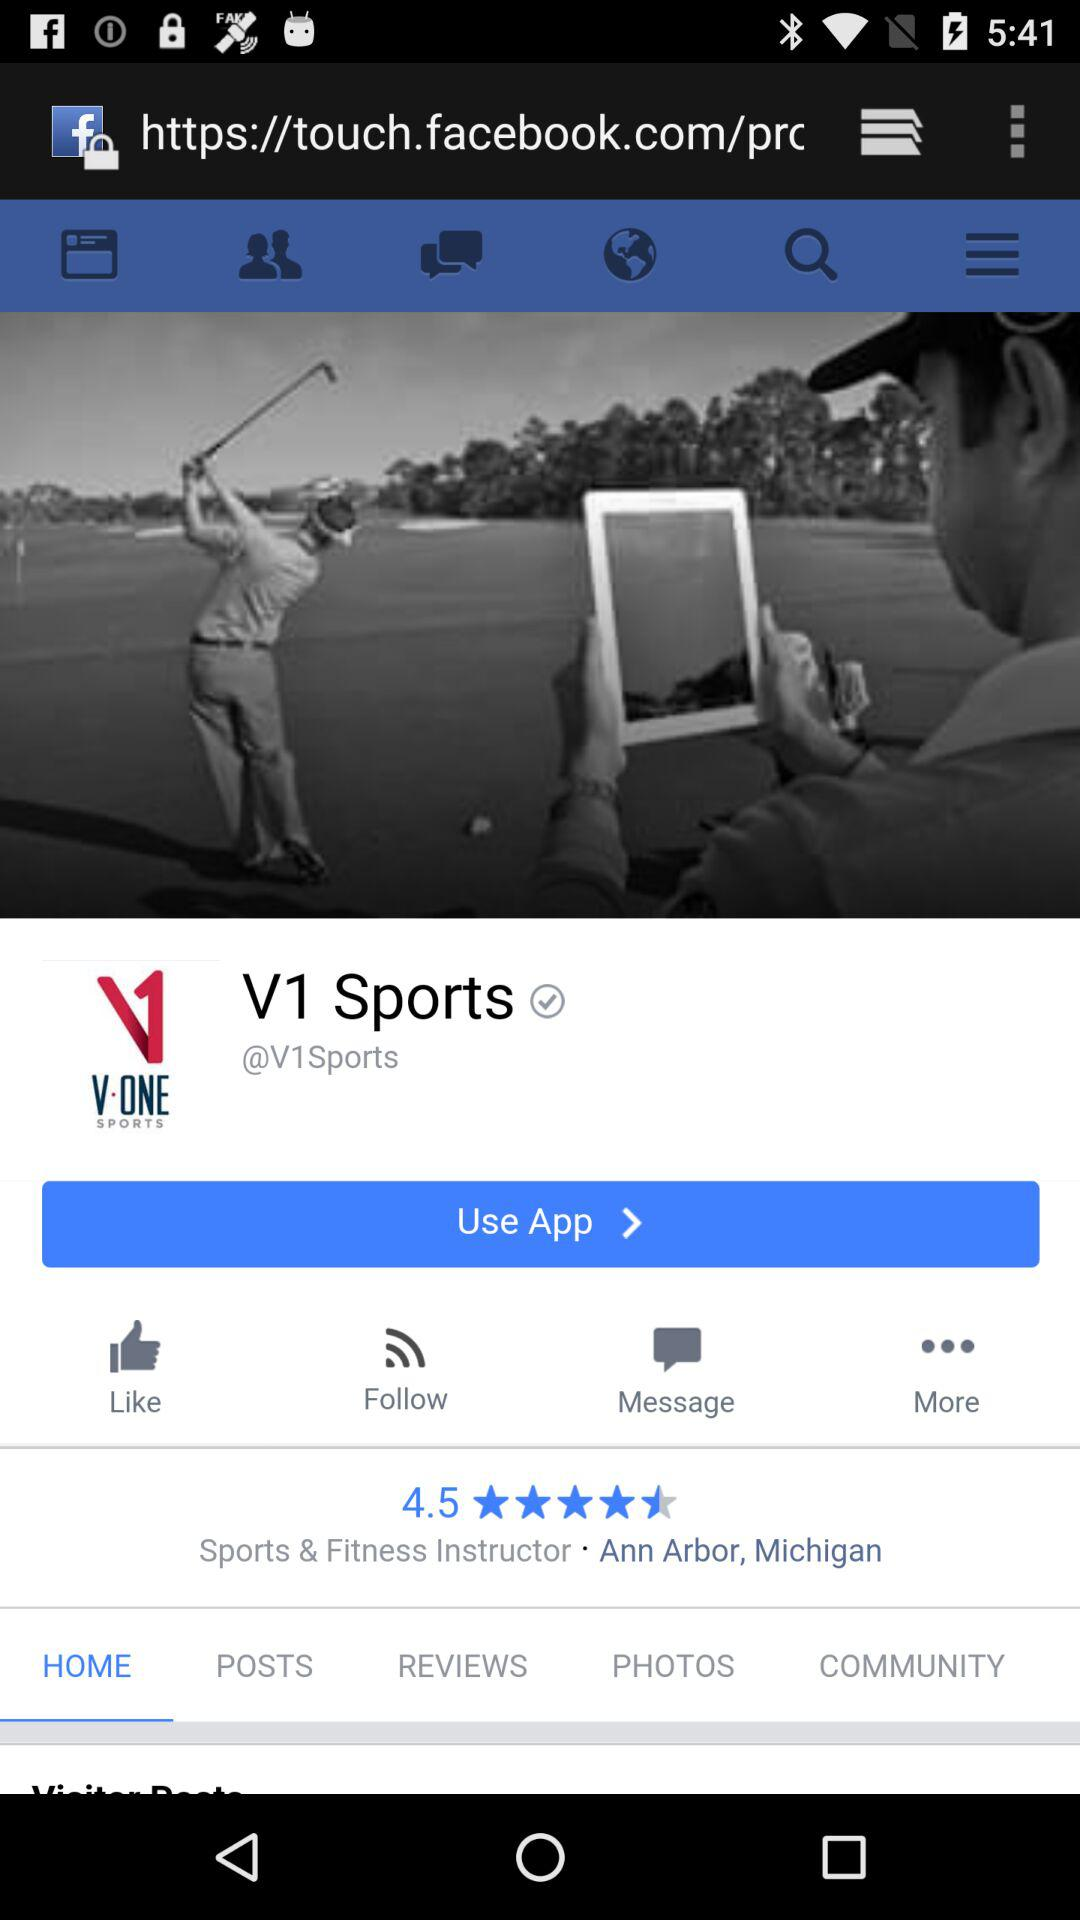Which tab is selected? The selected tab is "HOME". 